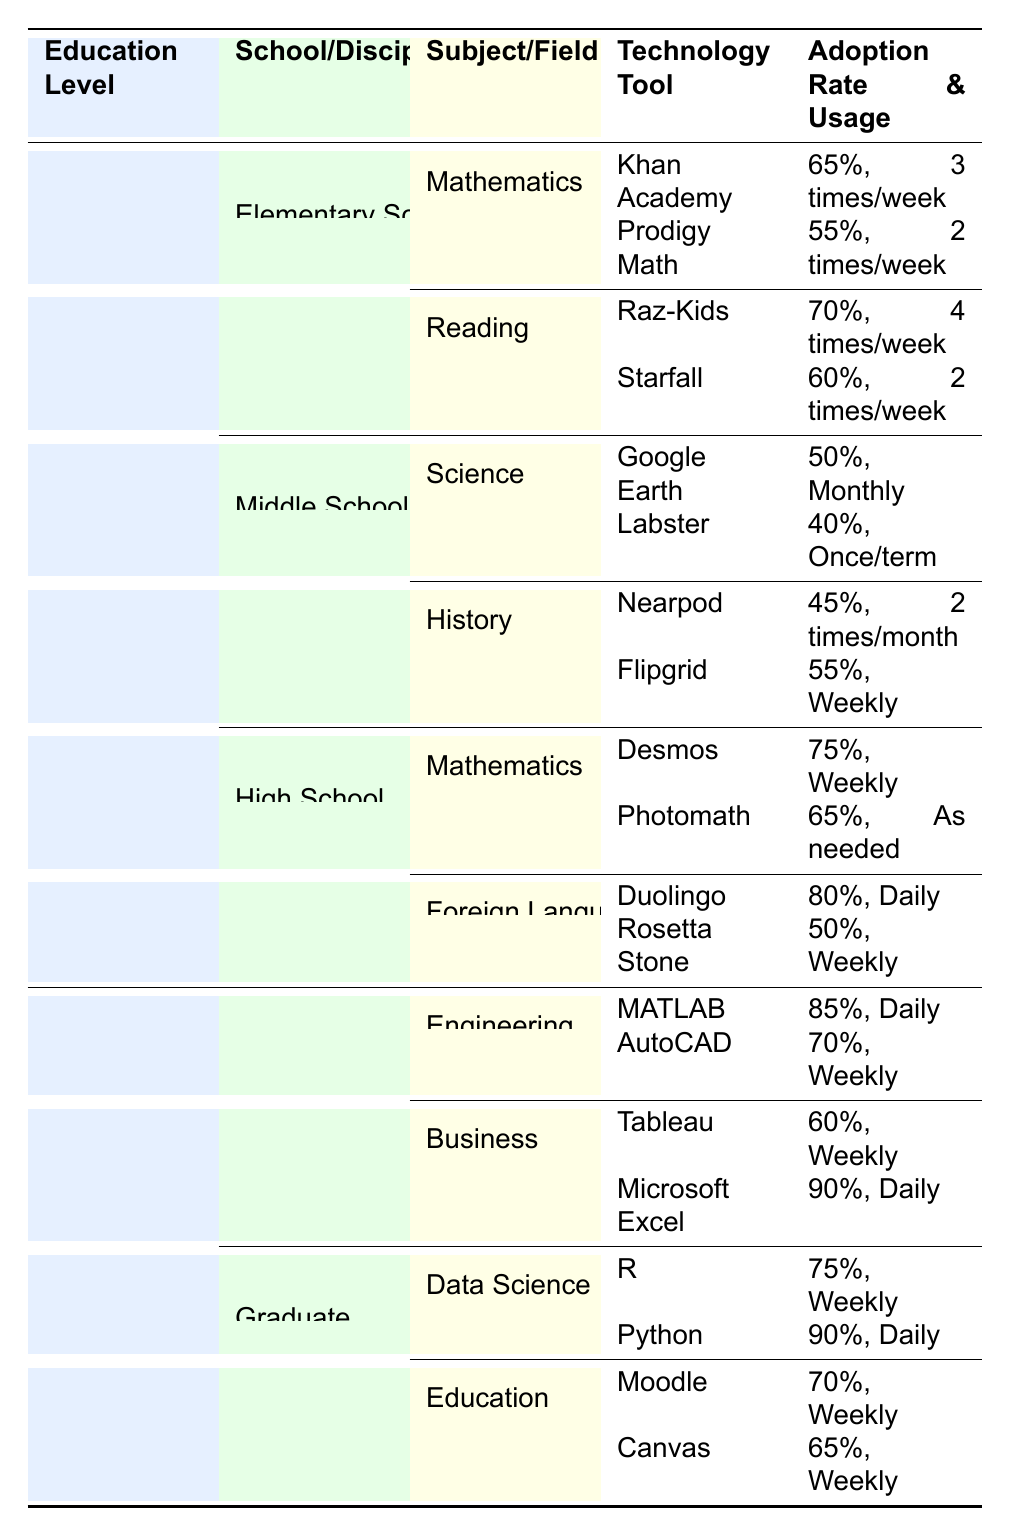What is the adoption rate of Khan Academy in elementary school mathematics? The table specifies that Khan Academy has an adoption rate of 65% in the subject of mathematics for elementary school.
Answer: 65% Which technology is used most frequently in elementary school reading? In elementary school reading, the technology with the highest usage frequency is Raz-Kids, which is used 4 times a week.
Answer: Raz-Kids What is the average adoption rate of technologies in middle school science? The adoption rates for technologies in middle school science are 50% for Google Earth and 40% for Labster. The average is (50 + 40)/2 = 45%.
Answer: 45% Is the usage frequency of Duolingo in high school foreign language daily? The table indicates that Duolingo is used daily in high school foreign language courses, confirming the statement as true.
Answer: Yes What is the difference in adoption rates between MATLAB and Tableau? MATLAB has an adoption rate of 85%, while Tableau has an adoption rate of 60%. The difference is 85% - 60% = 25%.
Answer: 25% Which technology in graduate education has the lowest adoption rate? In graduate education, the technology with the lowest adoption rate is Canvas, with 65%. This can be confirmed by examining the listed adoption rates under the discipline of Education.
Answer: Canvas How many technologies are adopted in high school mathematics? There are two technologies listed in high school mathematics: Desmos and Photomath. Therefore, the total is 2 technologies.
Answer: 2 Which subject in higher education has the highest adoption rate and what is the rate? The highest adoption rate is for Microsoft Excel in undergraduate business, which has an adoption rate of 90%. This can be found by reviewing all listed subjects and their corresponding rates.
Answer: Microsoft Excel, 90% What are the usage frequencies of Labster and Najpod? Labster is used once per term and Nearpod is used two times per month. This can be checked by referencing each technology's usage frequency under their respective subjects.
Answer: Labster: once/term, Nearpod: 2 times/month 